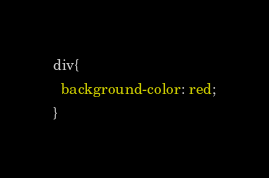Convert code to text. <code><loc_0><loc_0><loc_500><loc_500><_CSS_>div{
  background-color: red;
}
</code> 